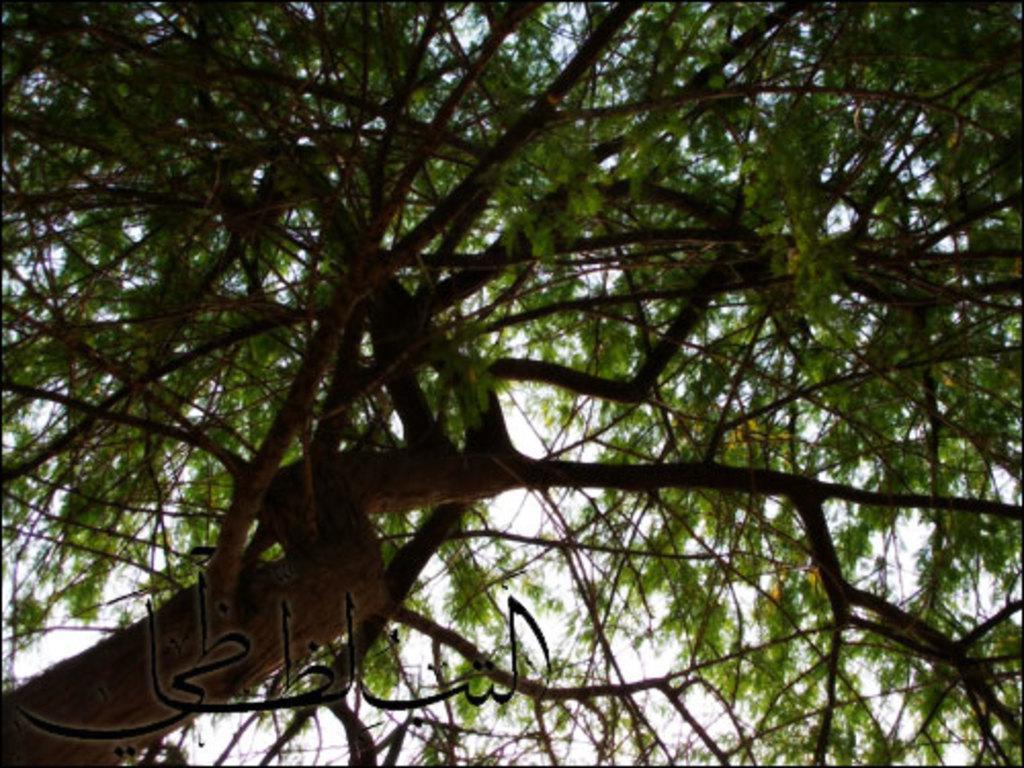Can you describe this image briefly? It is a zoom in picture of a tree. We can see a text at the bottom. 